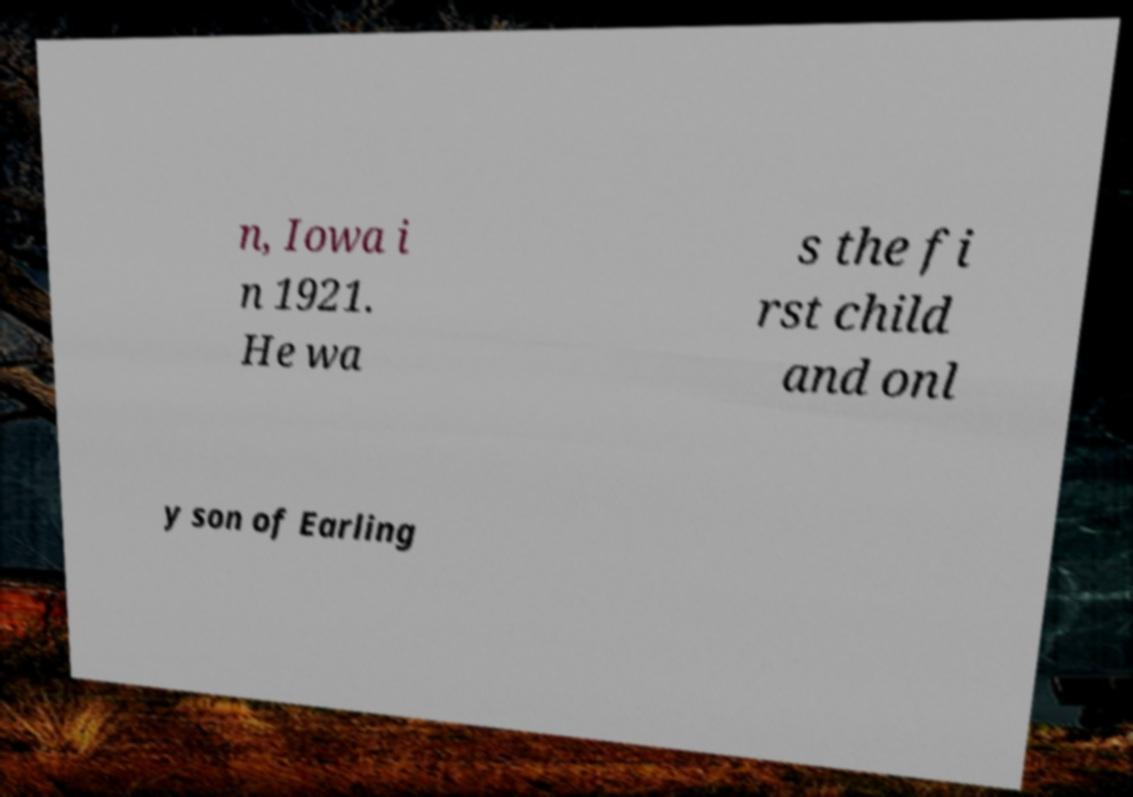What messages or text are displayed in this image? I need them in a readable, typed format. n, Iowa i n 1921. He wa s the fi rst child and onl y son of Earling 